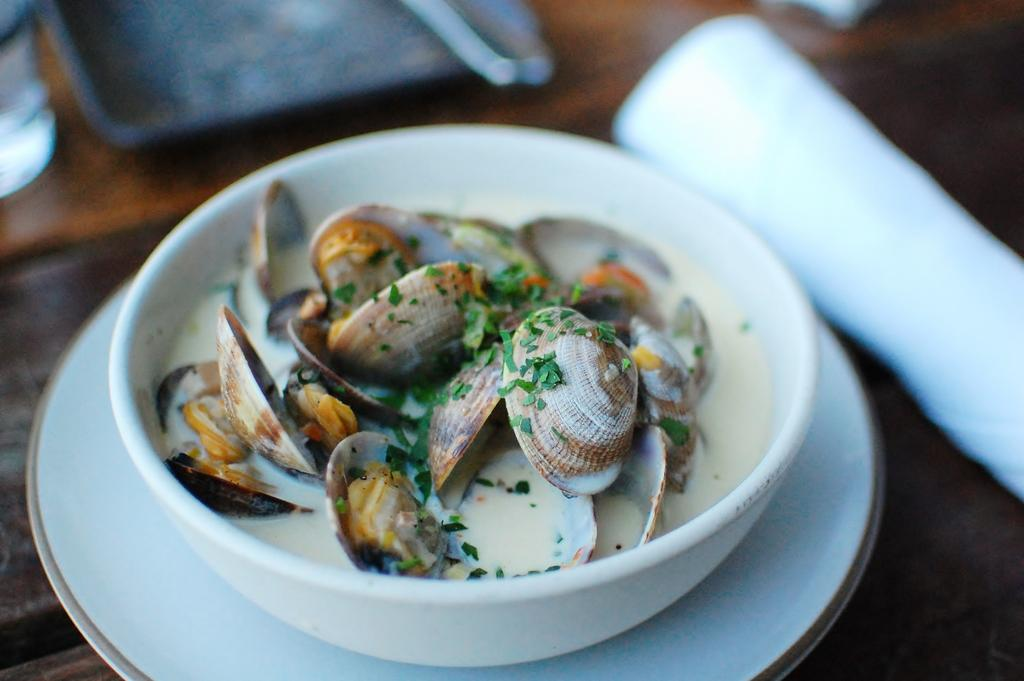What is in the bowl that is visible in the image? There is a bowl with food in the image. How is the bowl positioned in relation to other items? The bowl is on a plate. What is the purpose of the tray in the image? The tray is likely used to hold and transport the items in the image. What can be said about the color of the surface the items are on? The surface the items are on is brown in color. Can you describe any additional objects in the image? Yes, there are additional objects in the image, but their specific details are not mentioned in the provided facts. What grade does the bridge receive in the image? There is no bridge present in the image, so it is not possible to assign a grade. 